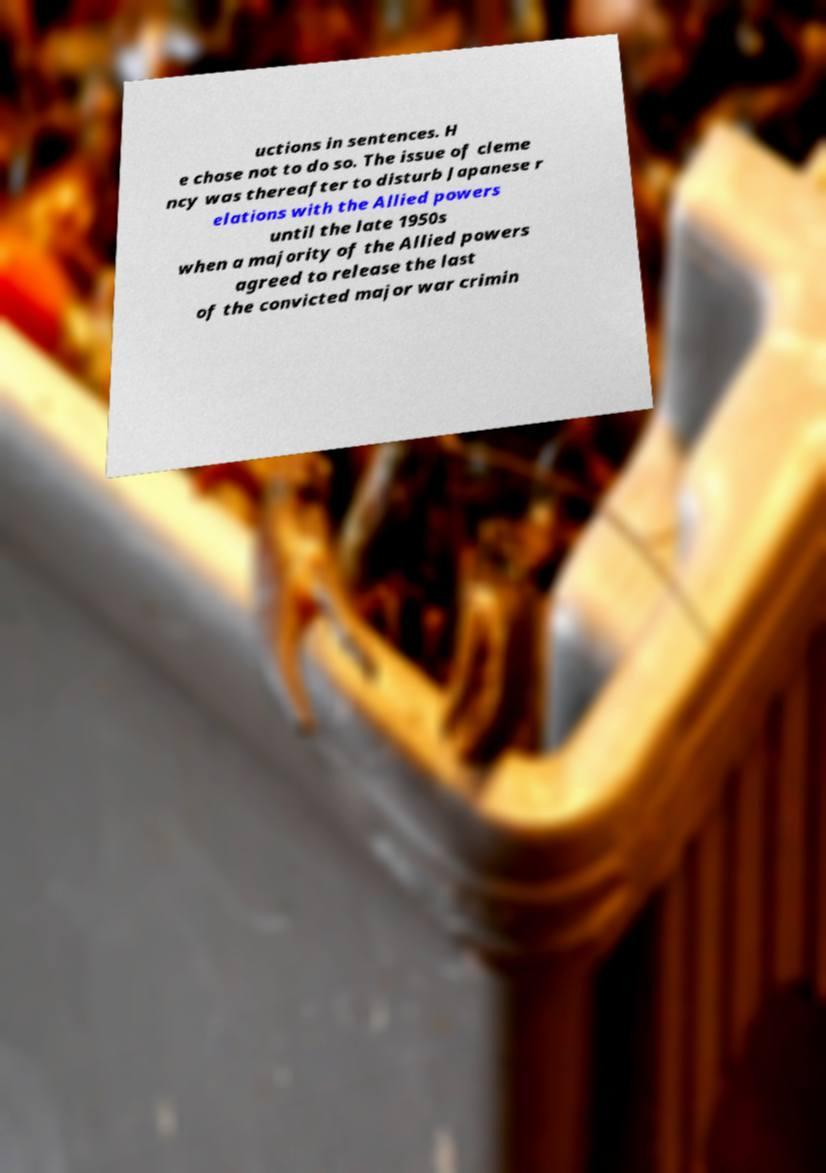I need the written content from this picture converted into text. Can you do that? uctions in sentences. H e chose not to do so. The issue of cleme ncy was thereafter to disturb Japanese r elations with the Allied powers until the late 1950s when a majority of the Allied powers agreed to release the last of the convicted major war crimin 